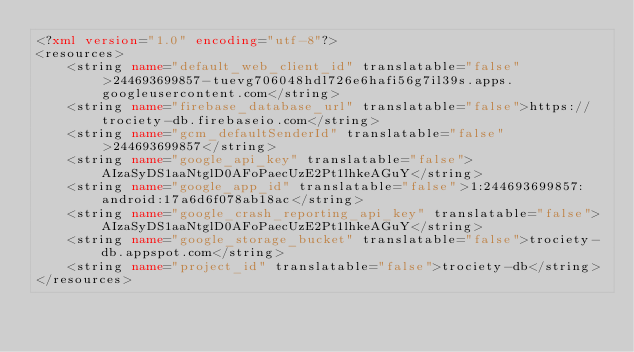<code> <loc_0><loc_0><loc_500><loc_500><_XML_><?xml version="1.0" encoding="utf-8"?>
<resources>
    <string name="default_web_client_id" translatable="false">244693699857-tuevg706048hdl726e6hafi56g7il39s.apps.googleusercontent.com</string>
    <string name="firebase_database_url" translatable="false">https://trociety-db.firebaseio.com</string>
    <string name="gcm_defaultSenderId" translatable="false">244693699857</string>
    <string name="google_api_key" translatable="false">AIzaSyDS1aaNtglD0AFoPaecUzE2Pt1lhkeAGuY</string>
    <string name="google_app_id" translatable="false">1:244693699857:android:17a6d6f078ab18ac</string>
    <string name="google_crash_reporting_api_key" translatable="false">AIzaSyDS1aaNtglD0AFoPaecUzE2Pt1lhkeAGuY</string>
    <string name="google_storage_bucket" translatable="false">trociety-db.appspot.com</string>
    <string name="project_id" translatable="false">trociety-db</string>
</resources>
</code> 